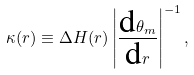Convert formula to latex. <formula><loc_0><loc_0><loc_500><loc_500>\kappa ( r ) \equiv \Delta H ( r ) \left | \frac { \text {d} \theta _ { m } } { \text {d} r } \right | ^ { - 1 } ,</formula> 